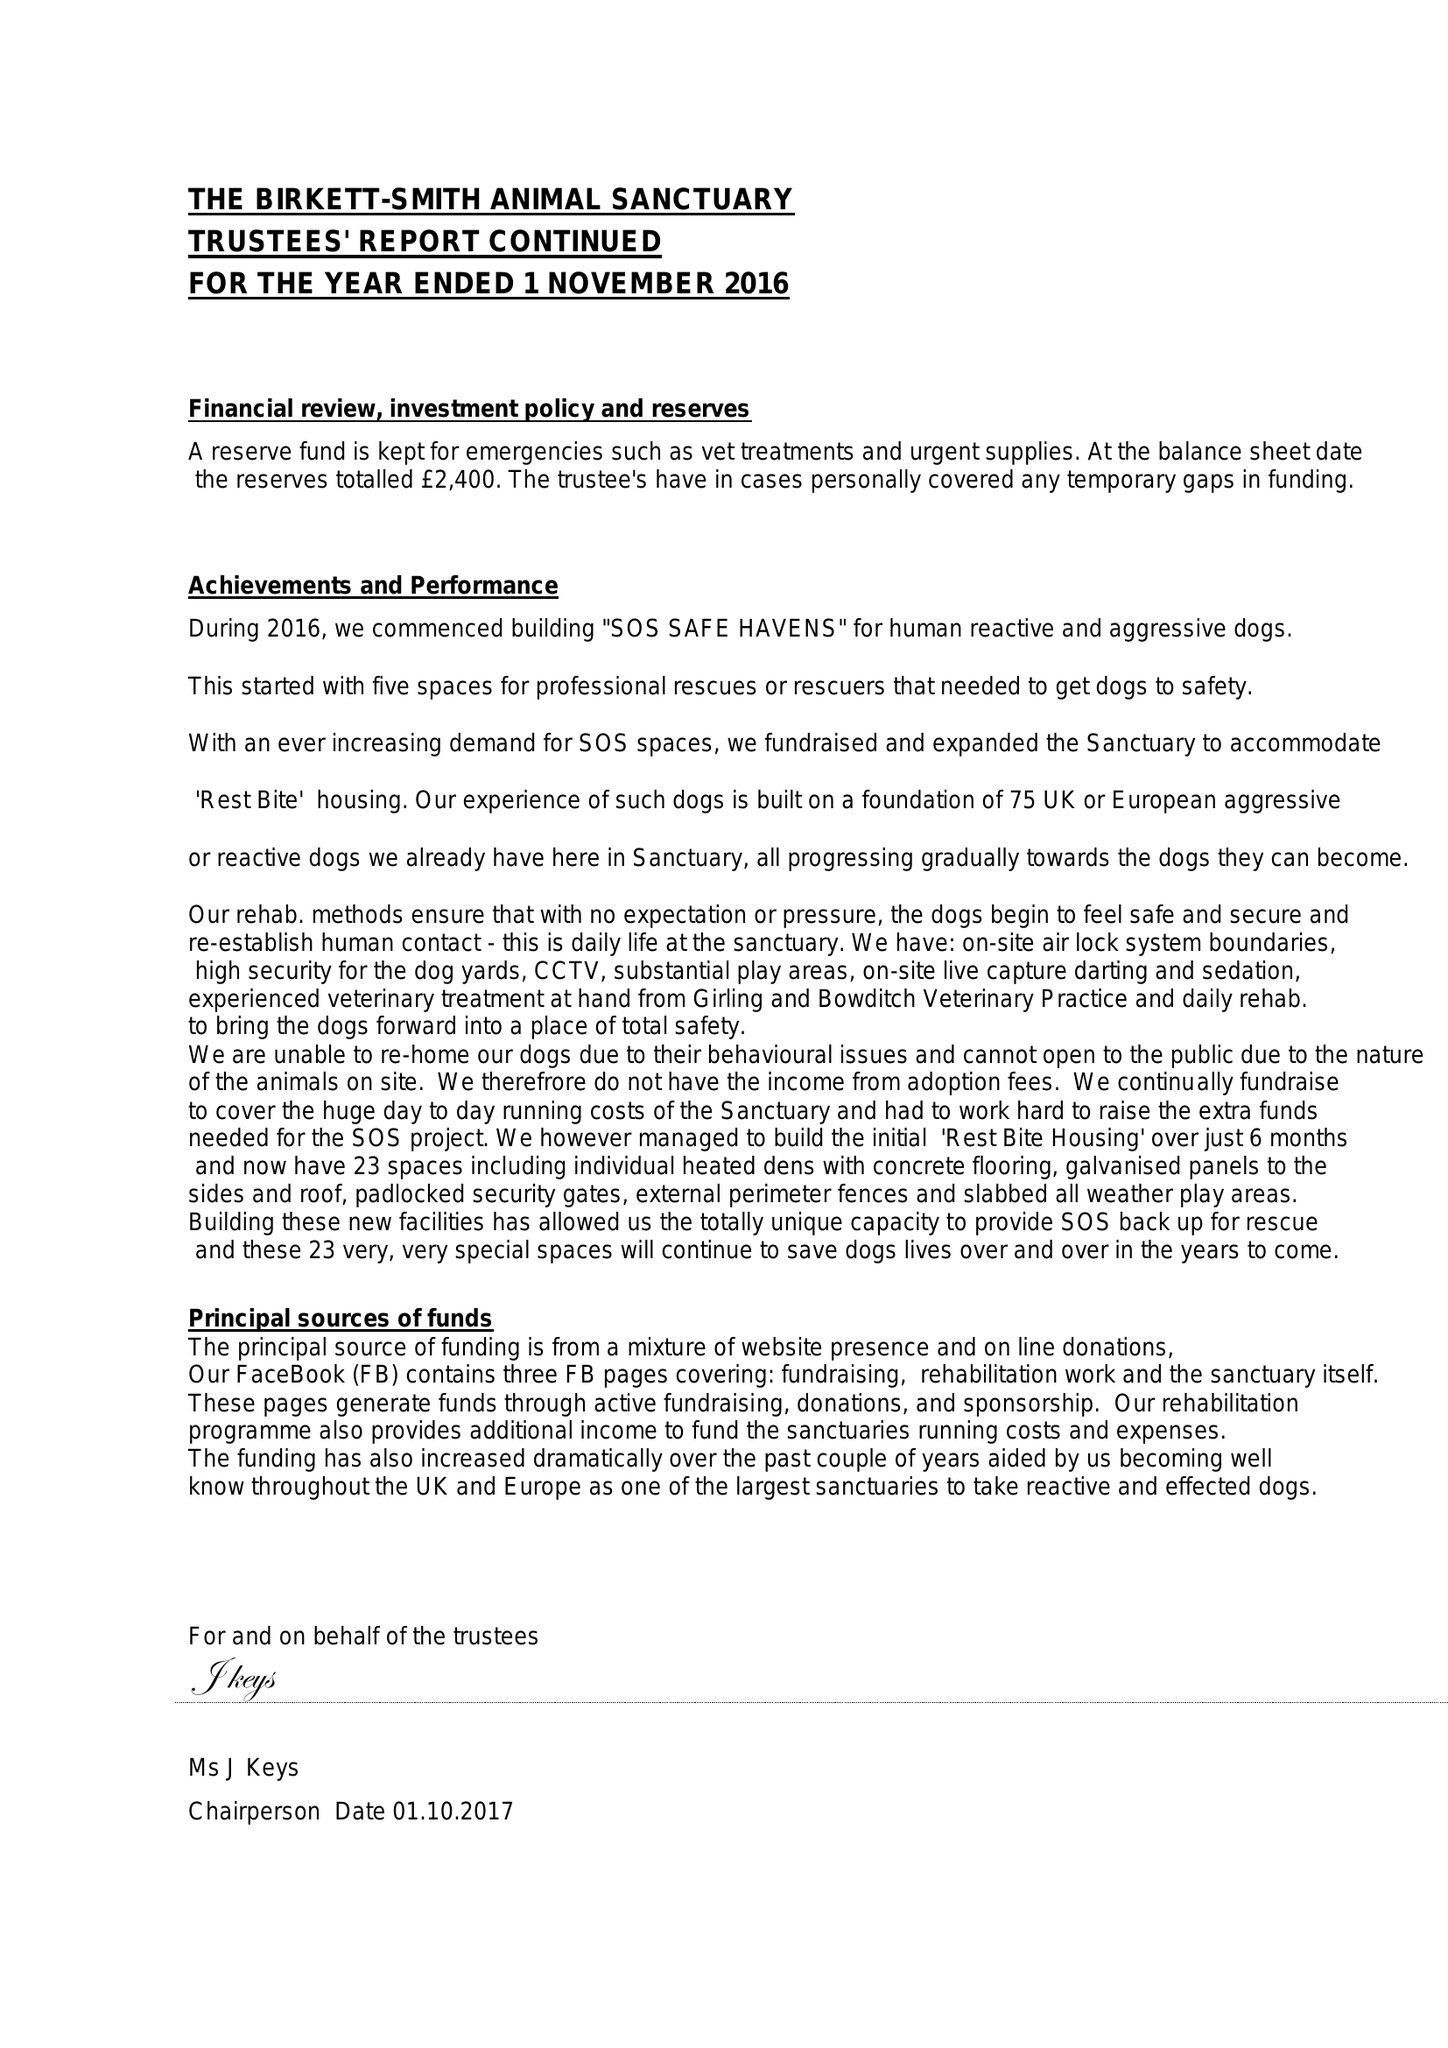What is the value for the charity_name?
Answer the question using a single word or phrase. The Birkett-Smith Animal Sanctuary 